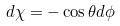<formula> <loc_0><loc_0><loc_500><loc_500>d \chi = - \cos \theta d \phi</formula> 